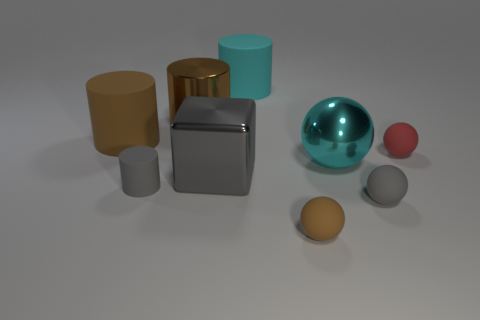Subtract all green cylinders. Subtract all blue spheres. How many cylinders are left? 4 Add 1 shiny cubes. How many objects exist? 10 Subtract all spheres. How many objects are left? 5 Add 5 big cubes. How many big cubes are left? 6 Add 6 big shiny blocks. How many big shiny blocks exist? 7 Subtract 0 yellow cylinders. How many objects are left? 9 Subtract all brown rubber objects. Subtract all large gray things. How many objects are left? 6 